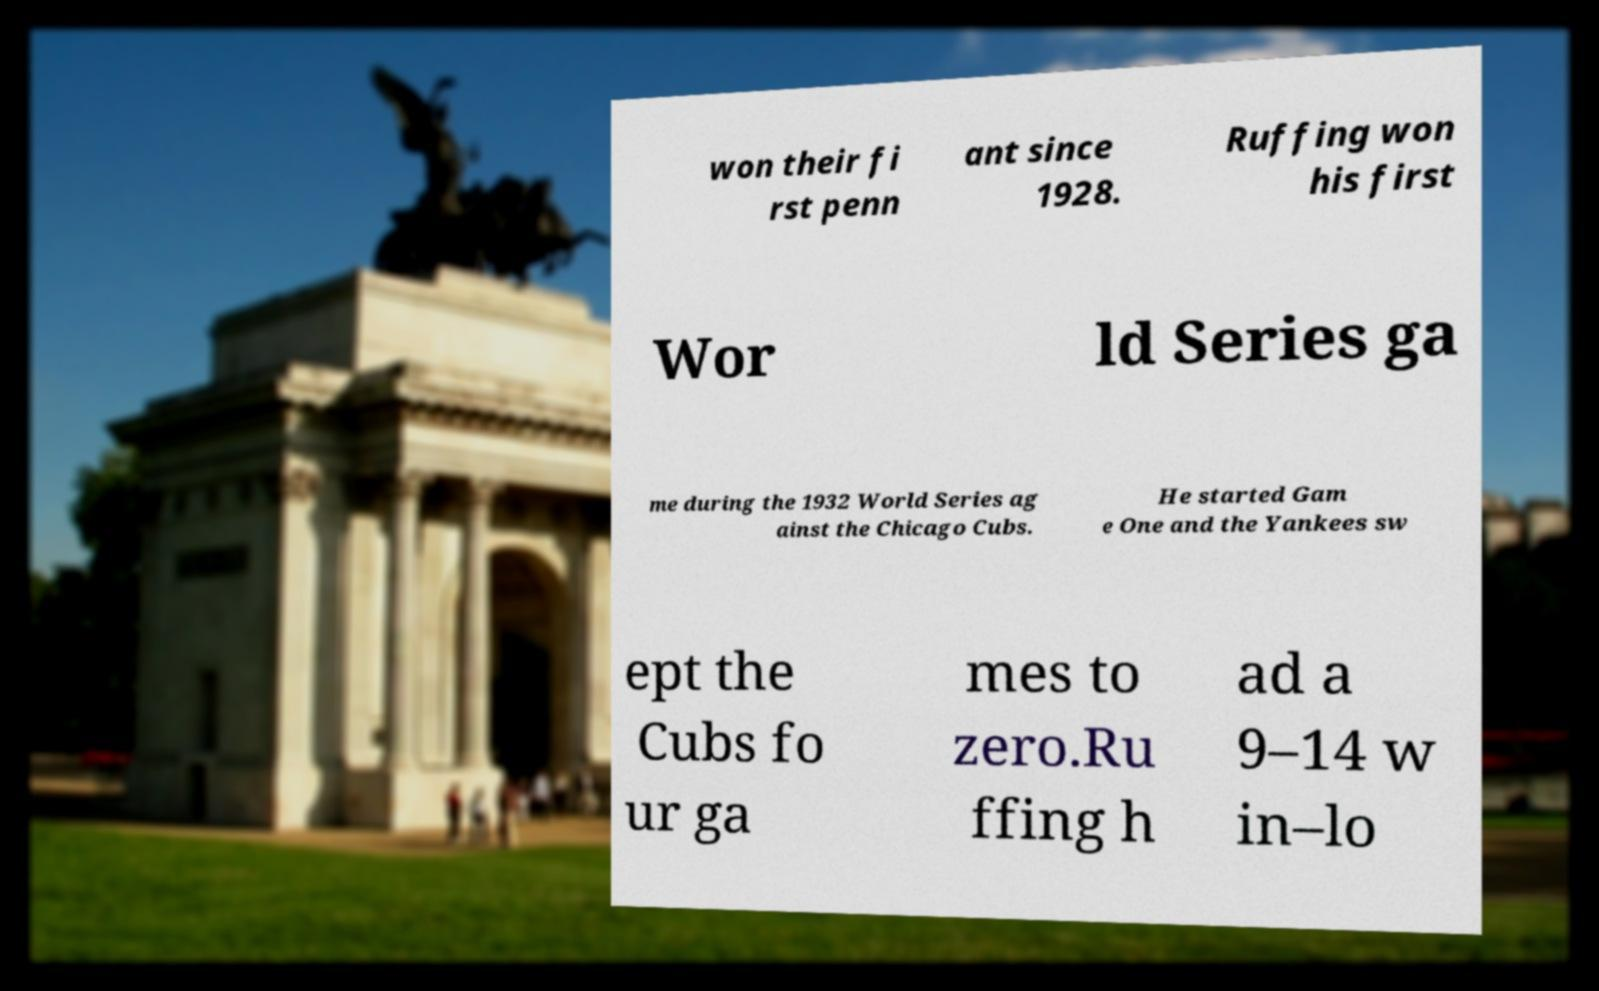There's text embedded in this image that I need extracted. Can you transcribe it verbatim? won their fi rst penn ant since 1928. Ruffing won his first Wor ld Series ga me during the 1932 World Series ag ainst the Chicago Cubs. He started Gam e One and the Yankees sw ept the Cubs fo ur ga mes to zero.Ru ffing h ad a 9–14 w in–lo 